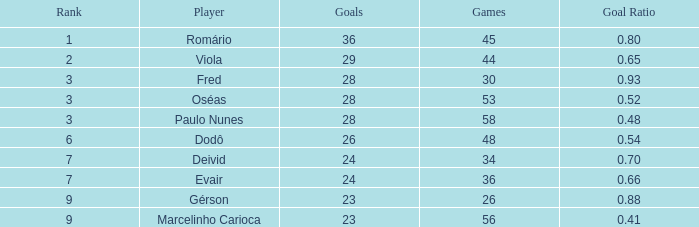With 56 games, how many goals possess a goal ratio under 0.8? 1.0. 